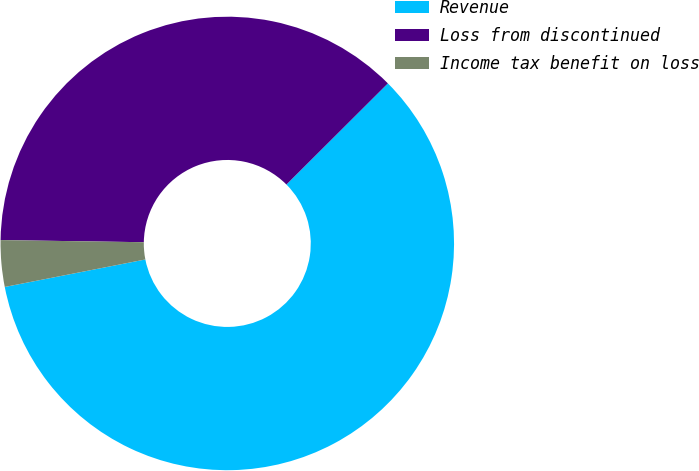<chart> <loc_0><loc_0><loc_500><loc_500><pie_chart><fcel>Revenue<fcel>Loss from discontinued<fcel>Income tax benefit on loss<nl><fcel>59.4%<fcel>37.29%<fcel>3.31%<nl></chart> 